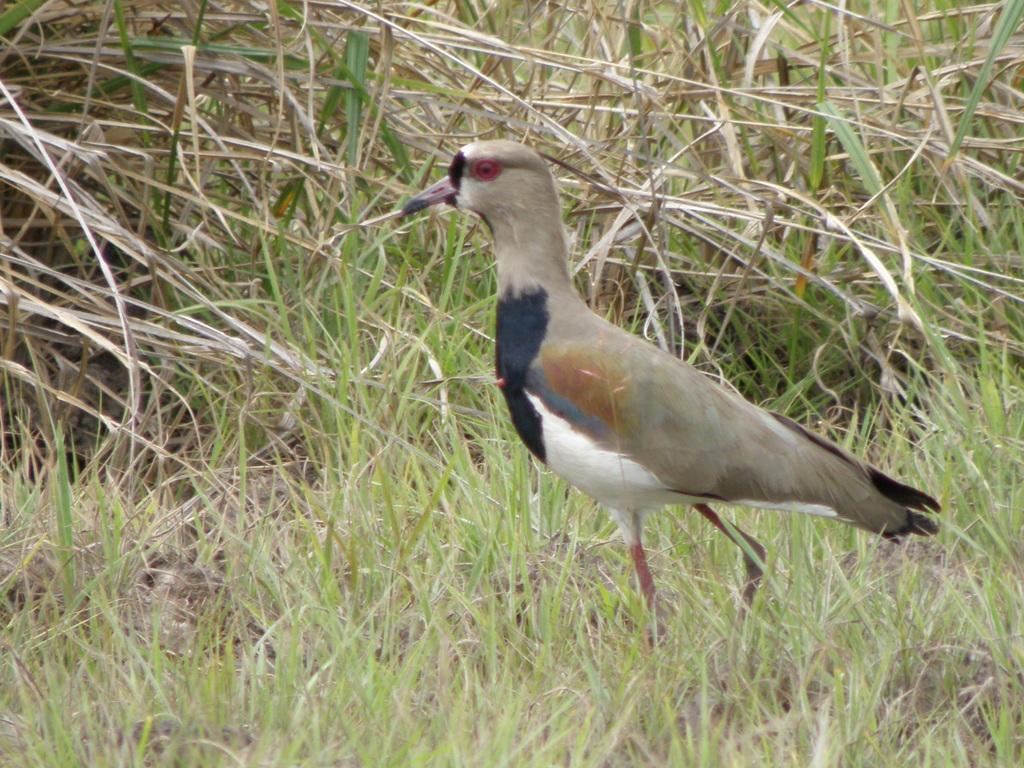Please provide a concise description of this image. In this image we can see the bird on the ground. And there are plants. 